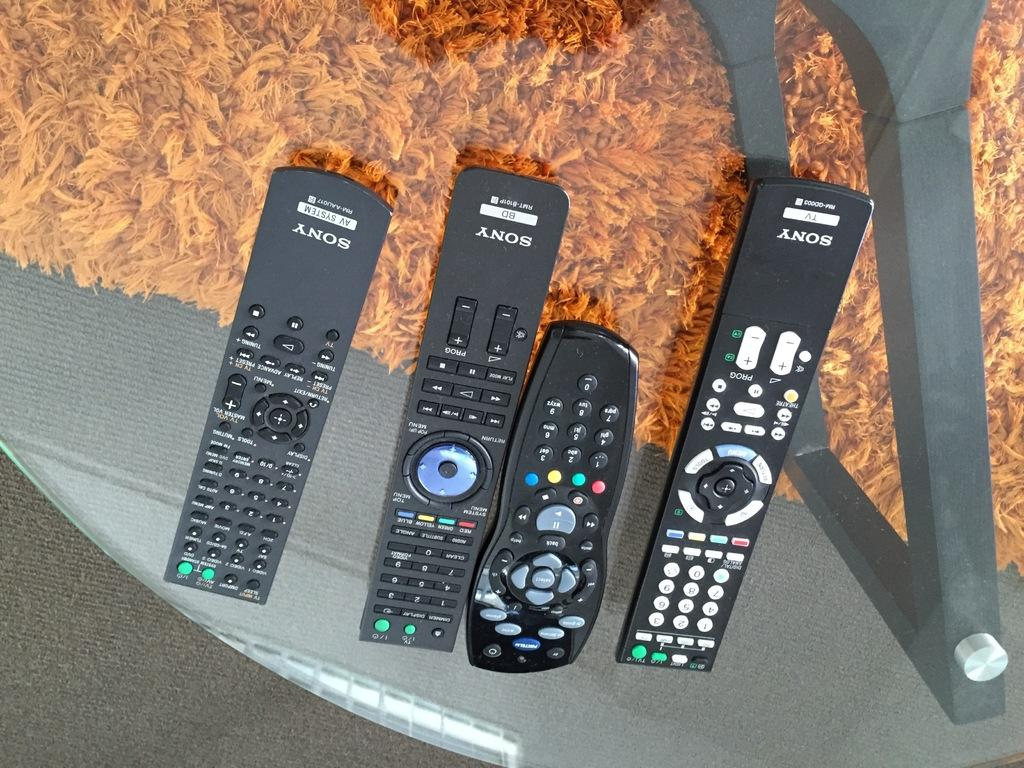<image>
Relay a brief, clear account of the picture shown. Four remotes are next to each other, three of which are Sony. 